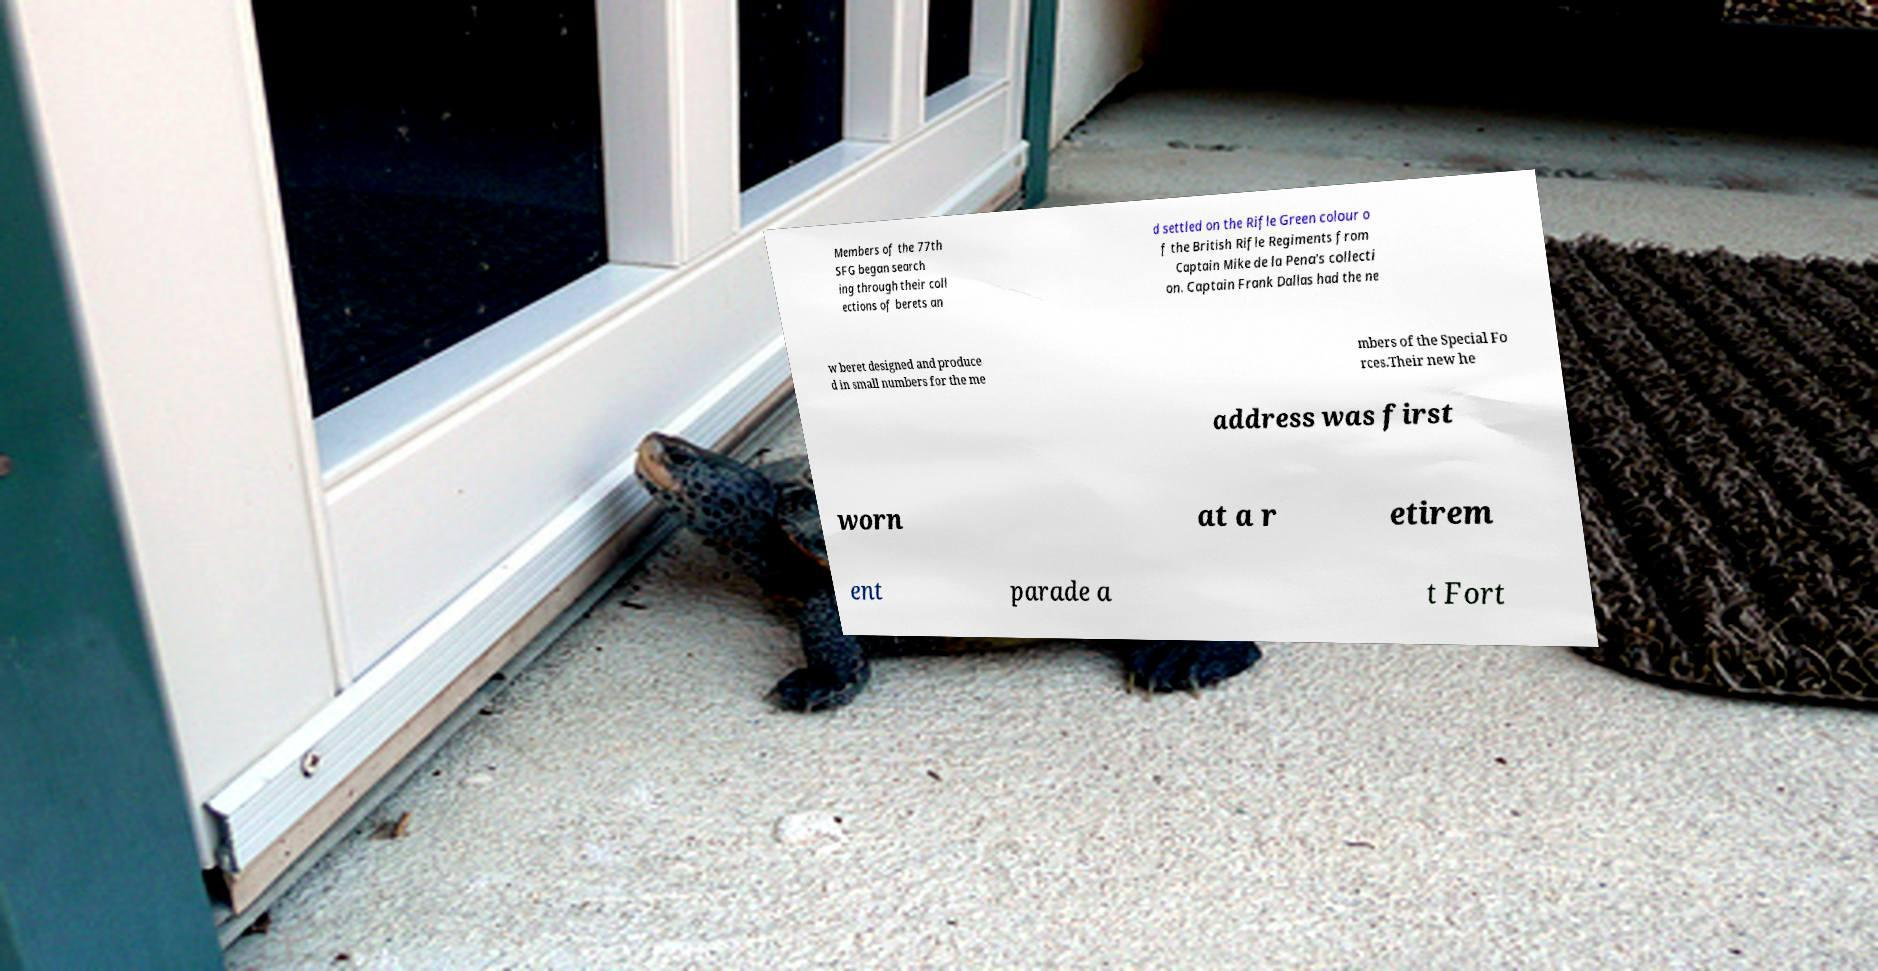Could you extract and type out the text from this image? Members of the 77th SFG began search ing through their coll ections of berets an d settled on the Rifle Green colour o f the British Rifle Regiments from Captain Mike de la Pena's collecti on. Captain Frank Dallas had the ne w beret designed and produce d in small numbers for the me mbers of the Special Fo rces.Their new he address was first worn at a r etirem ent parade a t Fort 